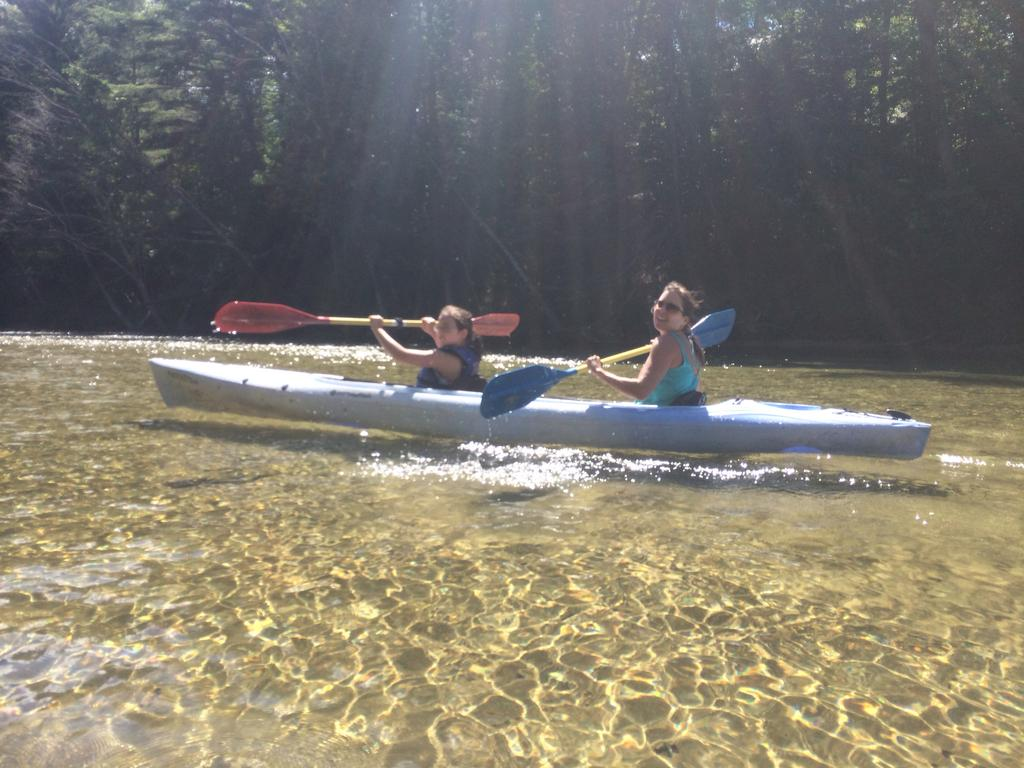What are the people in the image doing? The people in the image are sitting on a boat. What are the people holding while on the boat? The people are holding paddle boards. What can be seen in the background of the image? There are trees in the background of the image. What is visible at the bottom of the image? There is water visible at the bottom of the image. Can you see a basketball game happening on the boat in the image? No, there is no basketball game visible in the image. Is there a scarf being used as a prop in the image? There is no scarf present in the image. 